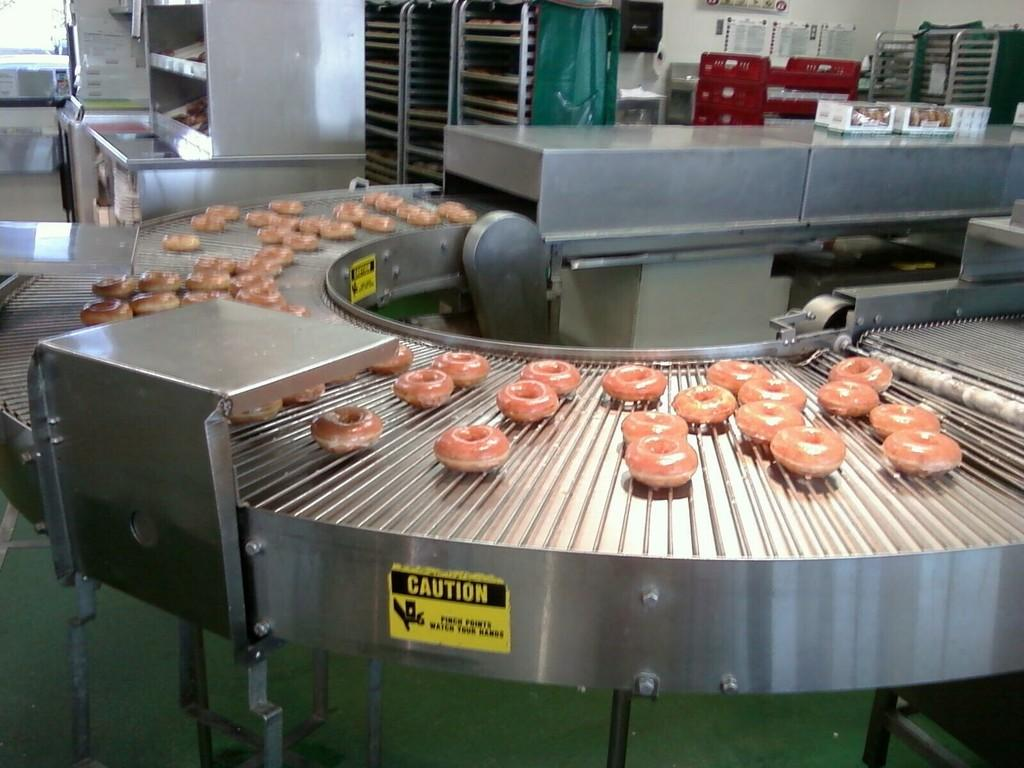<image>
Write a terse but informative summary of the picture. A caution sign is on the side of a conveyor belt with donuts on it. 